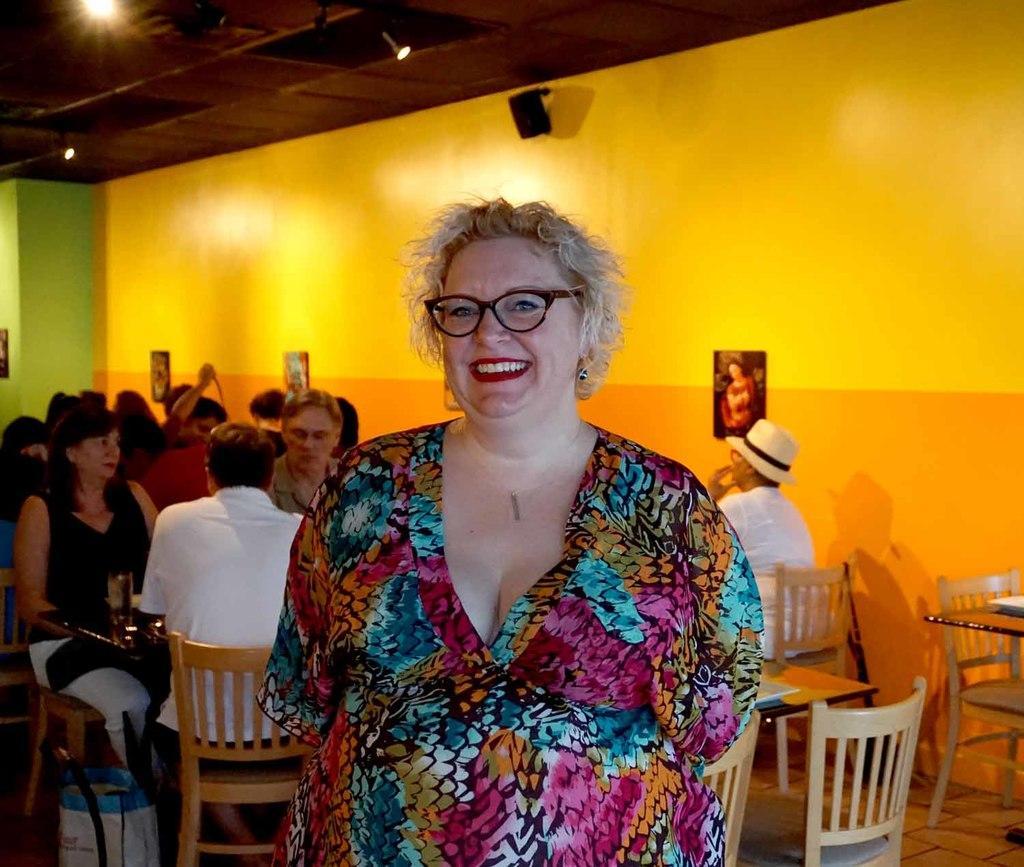Please provide a concise description of this image. In the foreground of the picture there is a woman standing, she is smiling. In the background there are chairs, tables and people sitting. In the background there is a wall. At the top there are lights to the ceiling. 